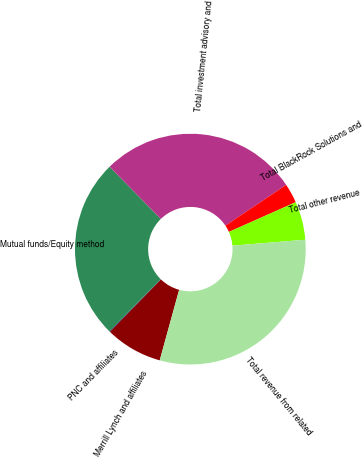Convert chart to OTSL. <chart><loc_0><loc_0><loc_500><loc_500><pie_chart><fcel>Merrill Lynch and affiliates<fcel>PNC and affiliates<fcel>Mutual funds/Equity method<fcel>Total investment advisory and<fcel>Total BlackRock Solutions and<fcel>Total other revenue<fcel>Total revenue from related<nl><fcel>8.01%<fcel>0.09%<fcel>25.29%<fcel>27.93%<fcel>2.73%<fcel>5.37%<fcel>30.57%<nl></chart> 